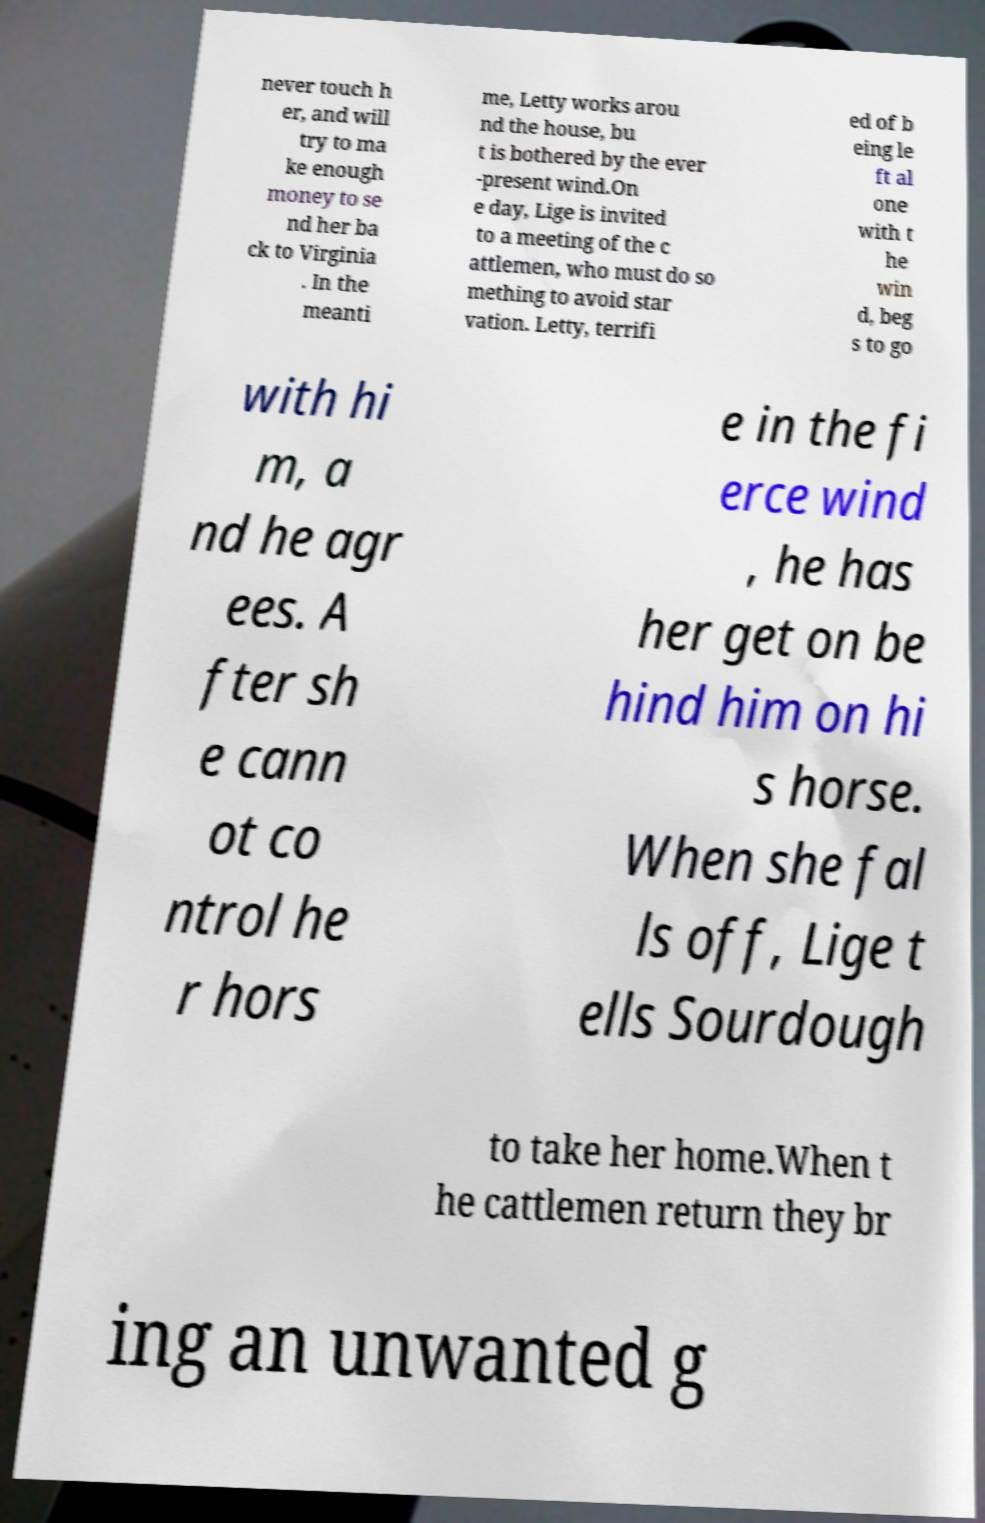Can you read and provide the text displayed in the image?This photo seems to have some interesting text. Can you extract and type it out for me? never touch h er, and will try to ma ke enough money to se nd her ba ck to Virginia . In the meanti me, Letty works arou nd the house, bu t is bothered by the ever -present wind.On e day, Lige is invited to a meeting of the c attlemen, who must do so mething to avoid star vation. Letty, terrifi ed of b eing le ft al one with t he win d, beg s to go with hi m, a nd he agr ees. A fter sh e cann ot co ntrol he r hors e in the fi erce wind , he has her get on be hind him on hi s horse. When she fal ls off, Lige t ells Sourdough to take her home.When t he cattlemen return they br ing an unwanted g 